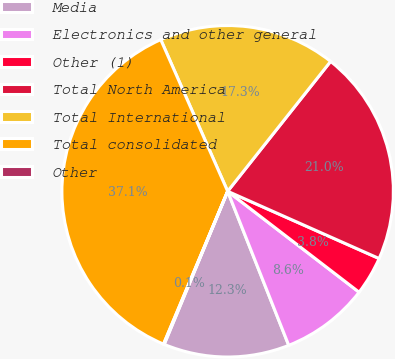Convert chart. <chart><loc_0><loc_0><loc_500><loc_500><pie_chart><fcel>Media<fcel>Electronics and other general<fcel>Other (1)<fcel>Total North America<fcel>Total International<fcel>Total consolidated<fcel>Other<nl><fcel>12.26%<fcel>8.57%<fcel>3.77%<fcel>20.98%<fcel>17.28%<fcel>37.06%<fcel>0.07%<nl></chart> 